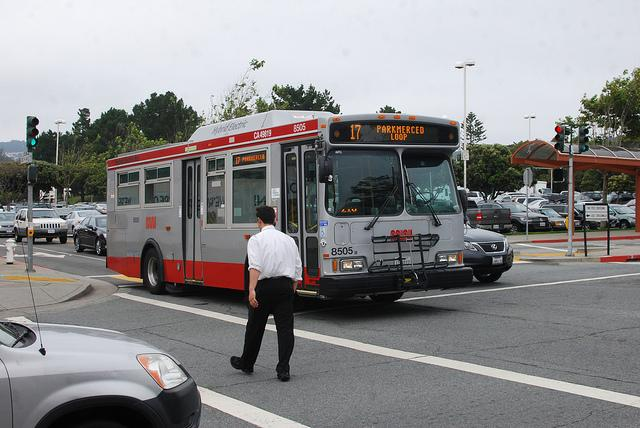After making one full circuit of their route starting from here where will this bus return? here 